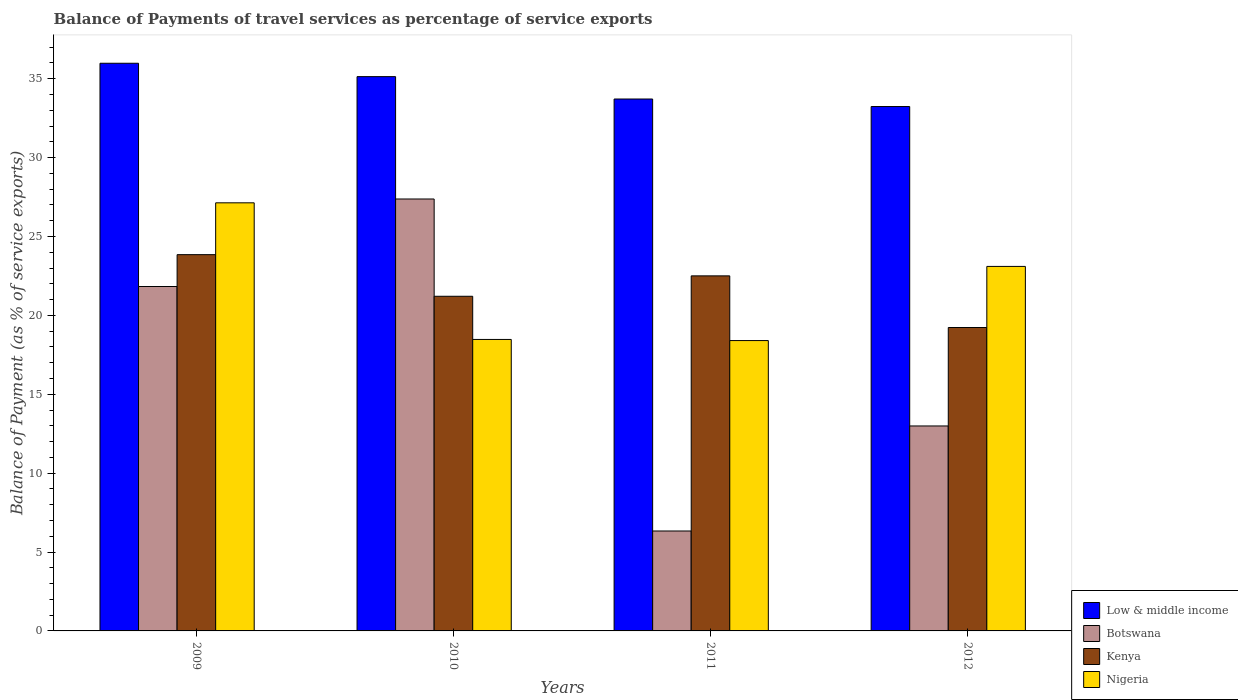How many bars are there on the 1st tick from the left?
Give a very brief answer. 4. What is the label of the 2nd group of bars from the left?
Offer a very short reply. 2010. In how many cases, is the number of bars for a given year not equal to the number of legend labels?
Give a very brief answer. 0. What is the balance of payments of travel services in Kenya in 2009?
Your answer should be compact. 23.85. Across all years, what is the maximum balance of payments of travel services in Nigeria?
Make the answer very short. 27.13. Across all years, what is the minimum balance of payments of travel services in Nigeria?
Keep it short and to the point. 18.4. In which year was the balance of payments of travel services in Botswana maximum?
Give a very brief answer. 2010. What is the total balance of payments of travel services in Nigeria in the graph?
Your response must be concise. 87.11. What is the difference between the balance of payments of travel services in Low & middle income in 2010 and that in 2011?
Your answer should be very brief. 1.42. What is the difference between the balance of payments of travel services in Botswana in 2011 and the balance of payments of travel services in Kenya in 2010?
Your response must be concise. -14.88. What is the average balance of payments of travel services in Low & middle income per year?
Give a very brief answer. 34.51. In the year 2010, what is the difference between the balance of payments of travel services in Botswana and balance of payments of travel services in Nigeria?
Your answer should be very brief. 8.9. What is the ratio of the balance of payments of travel services in Low & middle income in 2011 to that in 2012?
Give a very brief answer. 1.01. What is the difference between the highest and the second highest balance of payments of travel services in Botswana?
Ensure brevity in your answer.  5.55. What is the difference between the highest and the lowest balance of payments of travel services in Kenya?
Provide a succinct answer. 4.62. What does the 3rd bar from the left in 2012 represents?
Provide a short and direct response. Kenya. What does the 2nd bar from the right in 2009 represents?
Keep it short and to the point. Kenya. Is it the case that in every year, the sum of the balance of payments of travel services in Kenya and balance of payments of travel services in Nigeria is greater than the balance of payments of travel services in Botswana?
Keep it short and to the point. Yes. Are all the bars in the graph horizontal?
Provide a short and direct response. No. How many years are there in the graph?
Give a very brief answer. 4. What is the difference between two consecutive major ticks on the Y-axis?
Keep it short and to the point. 5. Does the graph contain any zero values?
Provide a short and direct response. No. Does the graph contain grids?
Your response must be concise. No. How many legend labels are there?
Provide a succinct answer. 4. How are the legend labels stacked?
Provide a succinct answer. Vertical. What is the title of the graph?
Ensure brevity in your answer.  Balance of Payments of travel services as percentage of service exports. Does "Nicaragua" appear as one of the legend labels in the graph?
Make the answer very short. No. What is the label or title of the X-axis?
Provide a short and direct response. Years. What is the label or title of the Y-axis?
Offer a very short reply. Balance of Payment (as % of service exports). What is the Balance of Payment (as % of service exports) of Low & middle income in 2009?
Give a very brief answer. 35.98. What is the Balance of Payment (as % of service exports) in Botswana in 2009?
Give a very brief answer. 21.83. What is the Balance of Payment (as % of service exports) of Kenya in 2009?
Provide a succinct answer. 23.85. What is the Balance of Payment (as % of service exports) in Nigeria in 2009?
Ensure brevity in your answer.  27.13. What is the Balance of Payment (as % of service exports) in Low & middle income in 2010?
Your answer should be compact. 35.13. What is the Balance of Payment (as % of service exports) of Botswana in 2010?
Make the answer very short. 27.38. What is the Balance of Payment (as % of service exports) in Kenya in 2010?
Your answer should be compact. 21.21. What is the Balance of Payment (as % of service exports) in Nigeria in 2010?
Provide a succinct answer. 18.47. What is the Balance of Payment (as % of service exports) of Low & middle income in 2011?
Keep it short and to the point. 33.71. What is the Balance of Payment (as % of service exports) of Botswana in 2011?
Offer a very short reply. 6.33. What is the Balance of Payment (as % of service exports) of Kenya in 2011?
Keep it short and to the point. 22.5. What is the Balance of Payment (as % of service exports) in Nigeria in 2011?
Make the answer very short. 18.4. What is the Balance of Payment (as % of service exports) of Low & middle income in 2012?
Your response must be concise. 33.23. What is the Balance of Payment (as % of service exports) of Botswana in 2012?
Offer a terse response. 12.99. What is the Balance of Payment (as % of service exports) of Kenya in 2012?
Keep it short and to the point. 19.23. What is the Balance of Payment (as % of service exports) in Nigeria in 2012?
Your answer should be very brief. 23.1. Across all years, what is the maximum Balance of Payment (as % of service exports) in Low & middle income?
Ensure brevity in your answer.  35.98. Across all years, what is the maximum Balance of Payment (as % of service exports) of Botswana?
Ensure brevity in your answer.  27.38. Across all years, what is the maximum Balance of Payment (as % of service exports) in Kenya?
Offer a terse response. 23.85. Across all years, what is the maximum Balance of Payment (as % of service exports) in Nigeria?
Offer a very short reply. 27.13. Across all years, what is the minimum Balance of Payment (as % of service exports) of Low & middle income?
Provide a short and direct response. 33.23. Across all years, what is the minimum Balance of Payment (as % of service exports) of Botswana?
Ensure brevity in your answer.  6.33. Across all years, what is the minimum Balance of Payment (as % of service exports) of Kenya?
Your answer should be compact. 19.23. Across all years, what is the minimum Balance of Payment (as % of service exports) in Nigeria?
Provide a short and direct response. 18.4. What is the total Balance of Payment (as % of service exports) in Low & middle income in the graph?
Keep it short and to the point. 138.06. What is the total Balance of Payment (as % of service exports) in Botswana in the graph?
Offer a terse response. 68.53. What is the total Balance of Payment (as % of service exports) in Kenya in the graph?
Make the answer very short. 86.79. What is the total Balance of Payment (as % of service exports) of Nigeria in the graph?
Your answer should be compact. 87.11. What is the difference between the Balance of Payment (as % of service exports) of Low & middle income in 2009 and that in 2010?
Keep it short and to the point. 0.85. What is the difference between the Balance of Payment (as % of service exports) of Botswana in 2009 and that in 2010?
Your answer should be very brief. -5.55. What is the difference between the Balance of Payment (as % of service exports) in Kenya in 2009 and that in 2010?
Keep it short and to the point. 2.64. What is the difference between the Balance of Payment (as % of service exports) in Nigeria in 2009 and that in 2010?
Keep it short and to the point. 8.66. What is the difference between the Balance of Payment (as % of service exports) of Low & middle income in 2009 and that in 2011?
Offer a very short reply. 2.27. What is the difference between the Balance of Payment (as % of service exports) of Botswana in 2009 and that in 2011?
Give a very brief answer. 15.5. What is the difference between the Balance of Payment (as % of service exports) of Kenya in 2009 and that in 2011?
Provide a succinct answer. 1.34. What is the difference between the Balance of Payment (as % of service exports) in Nigeria in 2009 and that in 2011?
Your answer should be compact. 8.73. What is the difference between the Balance of Payment (as % of service exports) of Low & middle income in 2009 and that in 2012?
Your answer should be very brief. 2.74. What is the difference between the Balance of Payment (as % of service exports) in Botswana in 2009 and that in 2012?
Your answer should be compact. 8.84. What is the difference between the Balance of Payment (as % of service exports) in Kenya in 2009 and that in 2012?
Keep it short and to the point. 4.62. What is the difference between the Balance of Payment (as % of service exports) of Nigeria in 2009 and that in 2012?
Your response must be concise. 4.03. What is the difference between the Balance of Payment (as % of service exports) in Low & middle income in 2010 and that in 2011?
Your answer should be very brief. 1.42. What is the difference between the Balance of Payment (as % of service exports) of Botswana in 2010 and that in 2011?
Provide a short and direct response. 21.04. What is the difference between the Balance of Payment (as % of service exports) in Kenya in 2010 and that in 2011?
Make the answer very short. -1.29. What is the difference between the Balance of Payment (as % of service exports) of Nigeria in 2010 and that in 2011?
Make the answer very short. 0.07. What is the difference between the Balance of Payment (as % of service exports) in Low & middle income in 2010 and that in 2012?
Ensure brevity in your answer.  1.9. What is the difference between the Balance of Payment (as % of service exports) of Botswana in 2010 and that in 2012?
Your answer should be very brief. 14.38. What is the difference between the Balance of Payment (as % of service exports) in Kenya in 2010 and that in 2012?
Keep it short and to the point. 1.98. What is the difference between the Balance of Payment (as % of service exports) of Nigeria in 2010 and that in 2012?
Keep it short and to the point. -4.63. What is the difference between the Balance of Payment (as % of service exports) of Low & middle income in 2011 and that in 2012?
Ensure brevity in your answer.  0.48. What is the difference between the Balance of Payment (as % of service exports) in Botswana in 2011 and that in 2012?
Make the answer very short. -6.66. What is the difference between the Balance of Payment (as % of service exports) of Kenya in 2011 and that in 2012?
Provide a short and direct response. 3.27. What is the difference between the Balance of Payment (as % of service exports) in Nigeria in 2011 and that in 2012?
Offer a very short reply. -4.7. What is the difference between the Balance of Payment (as % of service exports) in Low & middle income in 2009 and the Balance of Payment (as % of service exports) in Botswana in 2010?
Your answer should be very brief. 8.6. What is the difference between the Balance of Payment (as % of service exports) in Low & middle income in 2009 and the Balance of Payment (as % of service exports) in Kenya in 2010?
Offer a very short reply. 14.77. What is the difference between the Balance of Payment (as % of service exports) in Low & middle income in 2009 and the Balance of Payment (as % of service exports) in Nigeria in 2010?
Ensure brevity in your answer.  17.5. What is the difference between the Balance of Payment (as % of service exports) of Botswana in 2009 and the Balance of Payment (as % of service exports) of Kenya in 2010?
Your response must be concise. 0.62. What is the difference between the Balance of Payment (as % of service exports) of Botswana in 2009 and the Balance of Payment (as % of service exports) of Nigeria in 2010?
Give a very brief answer. 3.36. What is the difference between the Balance of Payment (as % of service exports) in Kenya in 2009 and the Balance of Payment (as % of service exports) in Nigeria in 2010?
Your answer should be very brief. 5.37. What is the difference between the Balance of Payment (as % of service exports) in Low & middle income in 2009 and the Balance of Payment (as % of service exports) in Botswana in 2011?
Offer a very short reply. 29.64. What is the difference between the Balance of Payment (as % of service exports) of Low & middle income in 2009 and the Balance of Payment (as % of service exports) of Kenya in 2011?
Offer a terse response. 13.47. What is the difference between the Balance of Payment (as % of service exports) of Low & middle income in 2009 and the Balance of Payment (as % of service exports) of Nigeria in 2011?
Your response must be concise. 17.58. What is the difference between the Balance of Payment (as % of service exports) in Botswana in 2009 and the Balance of Payment (as % of service exports) in Kenya in 2011?
Provide a succinct answer. -0.67. What is the difference between the Balance of Payment (as % of service exports) in Botswana in 2009 and the Balance of Payment (as % of service exports) in Nigeria in 2011?
Provide a succinct answer. 3.43. What is the difference between the Balance of Payment (as % of service exports) of Kenya in 2009 and the Balance of Payment (as % of service exports) of Nigeria in 2011?
Offer a terse response. 5.45. What is the difference between the Balance of Payment (as % of service exports) of Low & middle income in 2009 and the Balance of Payment (as % of service exports) of Botswana in 2012?
Your response must be concise. 22.99. What is the difference between the Balance of Payment (as % of service exports) of Low & middle income in 2009 and the Balance of Payment (as % of service exports) of Kenya in 2012?
Offer a very short reply. 16.75. What is the difference between the Balance of Payment (as % of service exports) in Low & middle income in 2009 and the Balance of Payment (as % of service exports) in Nigeria in 2012?
Keep it short and to the point. 12.88. What is the difference between the Balance of Payment (as % of service exports) of Botswana in 2009 and the Balance of Payment (as % of service exports) of Kenya in 2012?
Your answer should be very brief. 2.6. What is the difference between the Balance of Payment (as % of service exports) in Botswana in 2009 and the Balance of Payment (as % of service exports) in Nigeria in 2012?
Provide a succinct answer. -1.27. What is the difference between the Balance of Payment (as % of service exports) of Kenya in 2009 and the Balance of Payment (as % of service exports) of Nigeria in 2012?
Your answer should be very brief. 0.75. What is the difference between the Balance of Payment (as % of service exports) in Low & middle income in 2010 and the Balance of Payment (as % of service exports) in Botswana in 2011?
Keep it short and to the point. 28.8. What is the difference between the Balance of Payment (as % of service exports) in Low & middle income in 2010 and the Balance of Payment (as % of service exports) in Kenya in 2011?
Your answer should be compact. 12.63. What is the difference between the Balance of Payment (as % of service exports) of Low & middle income in 2010 and the Balance of Payment (as % of service exports) of Nigeria in 2011?
Provide a succinct answer. 16.73. What is the difference between the Balance of Payment (as % of service exports) of Botswana in 2010 and the Balance of Payment (as % of service exports) of Kenya in 2011?
Your response must be concise. 4.87. What is the difference between the Balance of Payment (as % of service exports) of Botswana in 2010 and the Balance of Payment (as % of service exports) of Nigeria in 2011?
Offer a very short reply. 8.97. What is the difference between the Balance of Payment (as % of service exports) of Kenya in 2010 and the Balance of Payment (as % of service exports) of Nigeria in 2011?
Give a very brief answer. 2.81. What is the difference between the Balance of Payment (as % of service exports) in Low & middle income in 2010 and the Balance of Payment (as % of service exports) in Botswana in 2012?
Provide a succinct answer. 22.14. What is the difference between the Balance of Payment (as % of service exports) in Low & middle income in 2010 and the Balance of Payment (as % of service exports) in Kenya in 2012?
Your answer should be very brief. 15.9. What is the difference between the Balance of Payment (as % of service exports) of Low & middle income in 2010 and the Balance of Payment (as % of service exports) of Nigeria in 2012?
Give a very brief answer. 12.03. What is the difference between the Balance of Payment (as % of service exports) in Botswana in 2010 and the Balance of Payment (as % of service exports) in Kenya in 2012?
Give a very brief answer. 8.14. What is the difference between the Balance of Payment (as % of service exports) in Botswana in 2010 and the Balance of Payment (as % of service exports) in Nigeria in 2012?
Your response must be concise. 4.27. What is the difference between the Balance of Payment (as % of service exports) in Kenya in 2010 and the Balance of Payment (as % of service exports) in Nigeria in 2012?
Your response must be concise. -1.89. What is the difference between the Balance of Payment (as % of service exports) of Low & middle income in 2011 and the Balance of Payment (as % of service exports) of Botswana in 2012?
Your response must be concise. 20.72. What is the difference between the Balance of Payment (as % of service exports) of Low & middle income in 2011 and the Balance of Payment (as % of service exports) of Kenya in 2012?
Your response must be concise. 14.48. What is the difference between the Balance of Payment (as % of service exports) of Low & middle income in 2011 and the Balance of Payment (as % of service exports) of Nigeria in 2012?
Your response must be concise. 10.61. What is the difference between the Balance of Payment (as % of service exports) of Botswana in 2011 and the Balance of Payment (as % of service exports) of Kenya in 2012?
Provide a short and direct response. -12.9. What is the difference between the Balance of Payment (as % of service exports) in Botswana in 2011 and the Balance of Payment (as % of service exports) in Nigeria in 2012?
Provide a short and direct response. -16.77. What is the difference between the Balance of Payment (as % of service exports) of Kenya in 2011 and the Balance of Payment (as % of service exports) of Nigeria in 2012?
Offer a terse response. -0.6. What is the average Balance of Payment (as % of service exports) of Low & middle income per year?
Offer a very short reply. 34.51. What is the average Balance of Payment (as % of service exports) of Botswana per year?
Keep it short and to the point. 17.13. What is the average Balance of Payment (as % of service exports) of Kenya per year?
Give a very brief answer. 21.7. What is the average Balance of Payment (as % of service exports) in Nigeria per year?
Provide a short and direct response. 21.78. In the year 2009, what is the difference between the Balance of Payment (as % of service exports) in Low & middle income and Balance of Payment (as % of service exports) in Botswana?
Make the answer very short. 14.15. In the year 2009, what is the difference between the Balance of Payment (as % of service exports) of Low & middle income and Balance of Payment (as % of service exports) of Kenya?
Your response must be concise. 12.13. In the year 2009, what is the difference between the Balance of Payment (as % of service exports) in Low & middle income and Balance of Payment (as % of service exports) in Nigeria?
Provide a short and direct response. 8.84. In the year 2009, what is the difference between the Balance of Payment (as % of service exports) of Botswana and Balance of Payment (as % of service exports) of Kenya?
Provide a short and direct response. -2.02. In the year 2009, what is the difference between the Balance of Payment (as % of service exports) in Botswana and Balance of Payment (as % of service exports) in Nigeria?
Ensure brevity in your answer.  -5.3. In the year 2009, what is the difference between the Balance of Payment (as % of service exports) of Kenya and Balance of Payment (as % of service exports) of Nigeria?
Give a very brief answer. -3.29. In the year 2010, what is the difference between the Balance of Payment (as % of service exports) of Low & middle income and Balance of Payment (as % of service exports) of Botswana?
Your answer should be very brief. 7.76. In the year 2010, what is the difference between the Balance of Payment (as % of service exports) of Low & middle income and Balance of Payment (as % of service exports) of Kenya?
Keep it short and to the point. 13.92. In the year 2010, what is the difference between the Balance of Payment (as % of service exports) of Low & middle income and Balance of Payment (as % of service exports) of Nigeria?
Your response must be concise. 16.66. In the year 2010, what is the difference between the Balance of Payment (as % of service exports) in Botswana and Balance of Payment (as % of service exports) in Kenya?
Provide a succinct answer. 6.17. In the year 2010, what is the difference between the Balance of Payment (as % of service exports) of Botswana and Balance of Payment (as % of service exports) of Nigeria?
Your response must be concise. 8.9. In the year 2010, what is the difference between the Balance of Payment (as % of service exports) of Kenya and Balance of Payment (as % of service exports) of Nigeria?
Your answer should be very brief. 2.74. In the year 2011, what is the difference between the Balance of Payment (as % of service exports) of Low & middle income and Balance of Payment (as % of service exports) of Botswana?
Your answer should be compact. 27.38. In the year 2011, what is the difference between the Balance of Payment (as % of service exports) in Low & middle income and Balance of Payment (as % of service exports) in Kenya?
Make the answer very short. 11.21. In the year 2011, what is the difference between the Balance of Payment (as % of service exports) in Low & middle income and Balance of Payment (as % of service exports) in Nigeria?
Your answer should be compact. 15.31. In the year 2011, what is the difference between the Balance of Payment (as % of service exports) in Botswana and Balance of Payment (as % of service exports) in Kenya?
Offer a terse response. -16.17. In the year 2011, what is the difference between the Balance of Payment (as % of service exports) in Botswana and Balance of Payment (as % of service exports) in Nigeria?
Your answer should be very brief. -12.07. In the year 2011, what is the difference between the Balance of Payment (as % of service exports) in Kenya and Balance of Payment (as % of service exports) in Nigeria?
Offer a very short reply. 4.1. In the year 2012, what is the difference between the Balance of Payment (as % of service exports) of Low & middle income and Balance of Payment (as % of service exports) of Botswana?
Give a very brief answer. 20.24. In the year 2012, what is the difference between the Balance of Payment (as % of service exports) in Low & middle income and Balance of Payment (as % of service exports) in Kenya?
Keep it short and to the point. 14. In the year 2012, what is the difference between the Balance of Payment (as % of service exports) of Low & middle income and Balance of Payment (as % of service exports) of Nigeria?
Your response must be concise. 10.13. In the year 2012, what is the difference between the Balance of Payment (as % of service exports) in Botswana and Balance of Payment (as % of service exports) in Kenya?
Offer a very short reply. -6.24. In the year 2012, what is the difference between the Balance of Payment (as % of service exports) of Botswana and Balance of Payment (as % of service exports) of Nigeria?
Offer a very short reply. -10.11. In the year 2012, what is the difference between the Balance of Payment (as % of service exports) of Kenya and Balance of Payment (as % of service exports) of Nigeria?
Offer a terse response. -3.87. What is the ratio of the Balance of Payment (as % of service exports) in Low & middle income in 2009 to that in 2010?
Offer a very short reply. 1.02. What is the ratio of the Balance of Payment (as % of service exports) of Botswana in 2009 to that in 2010?
Keep it short and to the point. 0.8. What is the ratio of the Balance of Payment (as % of service exports) of Kenya in 2009 to that in 2010?
Provide a succinct answer. 1.12. What is the ratio of the Balance of Payment (as % of service exports) in Nigeria in 2009 to that in 2010?
Your answer should be compact. 1.47. What is the ratio of the Balance of Payment (as % of service exports) in Low & middle income in 2009 to that in 2011?
Keep it short and to the point. 1.07. What is the ratio of the Balance of Payment (as % of service exports) in Botswana in 2009 to that in 2011?
Ensure brevity in your answer.  3.45. What is the ratio of the Balance of Payment (as % of service exports) of Kenya in 2009 to that in 2011?
Offer a terse response. 1.06. What is the ratio of the Balance of Payment (as % of service exports) of Nigeria in 2009 to that in 2011?
Provide a succinct answer. 1.47. What is the ratio of the Balance of Payment (as % of service exports) of Low & middle income in 2009 to that in 2012?
Your answer should be compact. 1.08. What is the ratio of the Balance of Payment (as % of service exports) of Botswana in 2009 to that in 2012?
Offer a very short reply. 1.68. What is the ratio of the Balance of Payment (as % of service exports) in Kenya in 2009 to that in 2012?
Offer a terse response. 1.24. What is the ratio of the Balance of Payment (as % of service exports) of Nigeria in 2009 to that in 2012?
Offer a very short reply. 1.17. What is the ratio of the Balance of Payment (as % of service exports) of Low & middle income in 2010 to that in 2011?
Keep it short and to the point. 1.04. What is the ratio of the Balance of Payment (as % of service exports) in Botswana in 2010 to that in 2011?
Your answer should be compact. 4.32. What is the ratio of the Balance of Payment (as % of service exports) in Kenya in 2010 to that in 2011?
Give a very brief answer. 0.94. What is the ratio of the Balance of Payment (as % of service exports) of Nigeria in 2010 to that in 2011?
Offer a very short reply. 1. What is the ratio of the Balance of Payment (as % of service exports) of Low & middle income in 2010 to that in 2012?
Provide a short and direct response. 1.06. What is the ratio of the Balance of Payment (as % of service exports) in Botswana in 2010 to that in 2012?
Make the answer very short. 2.11. What is the ratio of the Balance of Payment (as % of service exports) in Kenya in 2010 to that in 2012?
Give a very brief answer. 1.1. What is the ratio of the Balance of Payment (as % of service exports) in Nigeria in 2010 to that in 2012?
Keep it short and to the point. 0.8. What is the ratio of the Balance of Payment (as % of service exports) of Low & middle income in 2011 to that in 2012?
Offer a terse response. 1.01. What is the ratio of the Balance of Payment (as % of service exports) in Botswana in 2011 to that in 2012?
Provide a succinct answer. 0.49. What is the ratio of the Balance of Payment (as % of service exports) of Kenya in 2011 to that in 2012?
Provide a succinct answer. 1.17. What is the ratio of the Balance of Payment (as % of service exports) of Nigeria in 2011 to that in 2012?
Keep it short and to the point. 0.8. What is the difference between the highest and the second highest Balance of Payment (as % of service exports) of Low & middle income?
Your answer should be very brief. 0.85. What is the difference between the highest and the second highest Balance of Payment (as % of service exports) in Botswana?
Your answer should be compact. 5.55. What is the difference between the highest and the second highest Balance of Payment (as % of service exports) in Kenya?
Give a very brief answer. 1.34. What is the difference between the highest and the second highest Balance of Payment (as % of service exports) of Nigeria?
Make the answer very short. 4.03. What is the difference between the highest and the lowest Balance of Payment (as % of service exports) of Low & middle income?
Ensure brevity in your answer.  2.74. What is the difference between the highest and the lowest Balance of Payment (as % of service exports) in Botswana?
Provide a short and direct response. 21.04. What is the difference between the highest and the lowest Balance of Payment (as % of service exports) of Kenya?
Provide a succinct answer. 4.62. What is the difference between the highest and the lowest Balance of Payment (as % of service exports) of Nigeria?
Your answer should be compact. 8.73. 